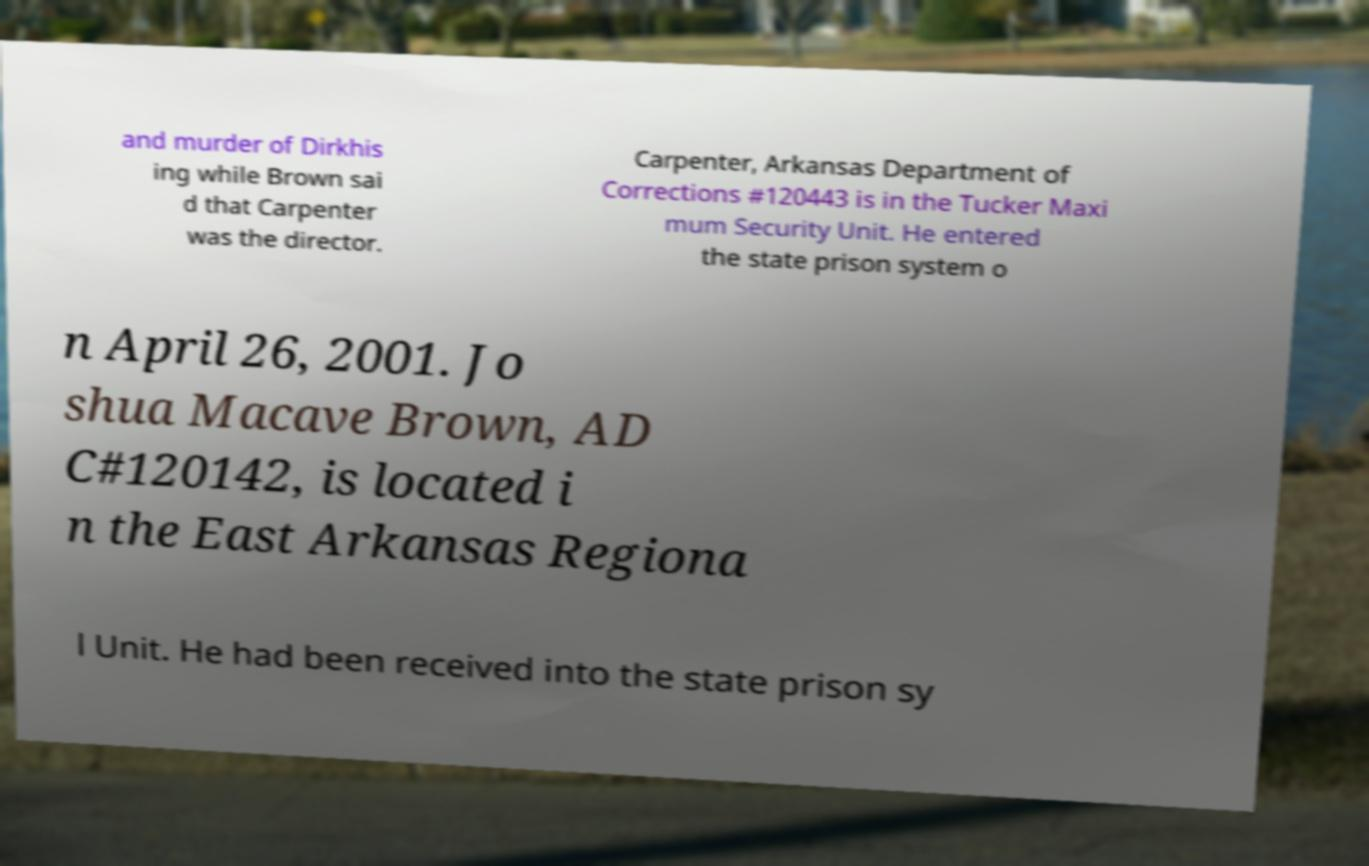Please read and relay the text visible in this image. What does it say? and murder of Dirkhis ing while Brown sai d that Carpenter was the director. Carpenter, Arkansas Department of Corrections #120443 is in the Tucker Maxi mum Security Unit. He entered the state prison system o n April 26, 2001. Jo shua Macave Brown, AD C#120142, is located i n the East Arkansas Regiona l Unit. He had been received into the state prison sy 